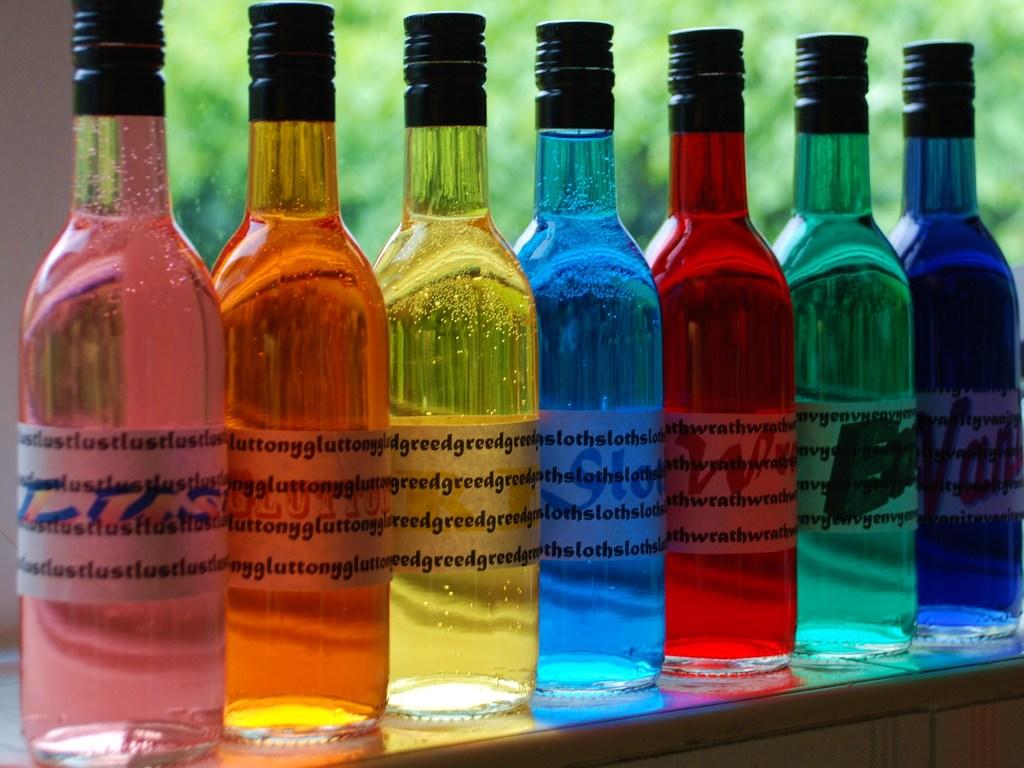The yellow bottle has what word repeated over the label?
Give a very brief answer. Greed. How does the blue bottle make you feel?
Provide a short and direct response. Answering does not require reading text in the image. 